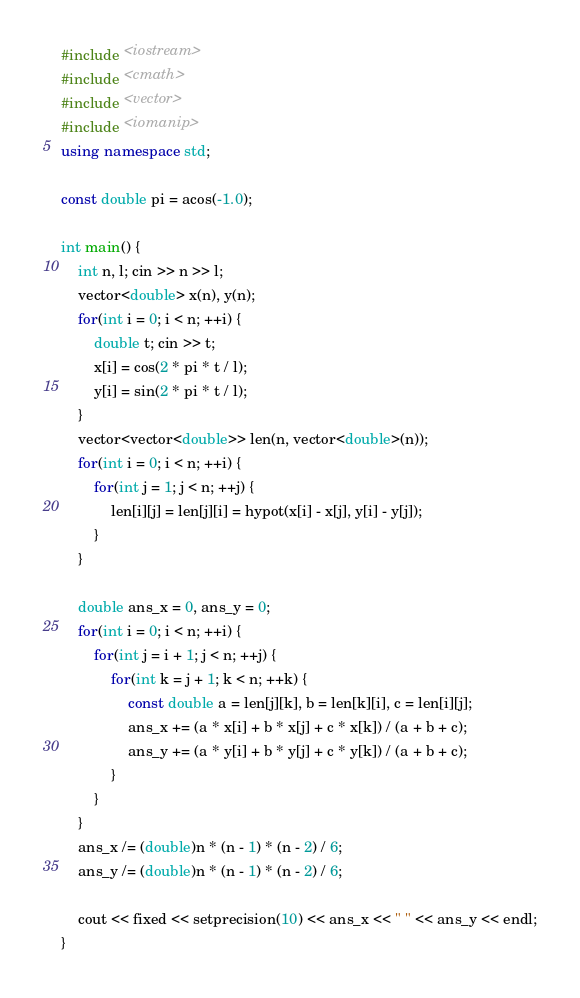<code> <loc_0><loc_0><loc_500><loc_500><_C++_>#include <iostream>
#include <cmath>
#include <vector>
#include <iomanip>
using namespace std;

const double pi = acos(-1.0);

int main() {
    int n, l; cin >> n >> l;
    vector<double> x(n), y(n);
    for(int i = 0; i < n; ++i) {
        double t; cin >> t;
        x[i] = cos(2 * pi * t / l);
        y[i] = sin(2 * pi * t / l);
    }
    vector<vector<double>> len(n, vector<double>(n));
    for(int i = 0; i < n; ++i) {
        for(int j = 1; j < n; ++j) {
            len[i][j] = len[j][i] = hypot(x[i] - x[j], y[i] - y[j]);
        }
    }

    double ans_x = 0, ans_y = 0;
    for(int i = 0; i < n; ++i) {
        for(int j = i + 1; j < n; ++j) {
            for(int k = j + 1; k < n; ++k) {
                const double a = len[j][k], b = len[k][i], c = len[i][j];
                ans_x += (a * x[i] + b * x[j] + c * x[k]) / (a + b + c);
                ans_y += (a * y[i] + b * y[j] + c * y[k]) / (a + b + c);
            }
        }
    }
    ans_x /= (double)n * (n - 1) * (n - 2) / 6;
    ans_y /= (double)n * (n - 1) * (n - 2) / 6;

    cout << fixed << setprecision(10) << ans_x << " " << ans_y << endl;
}
</code> 